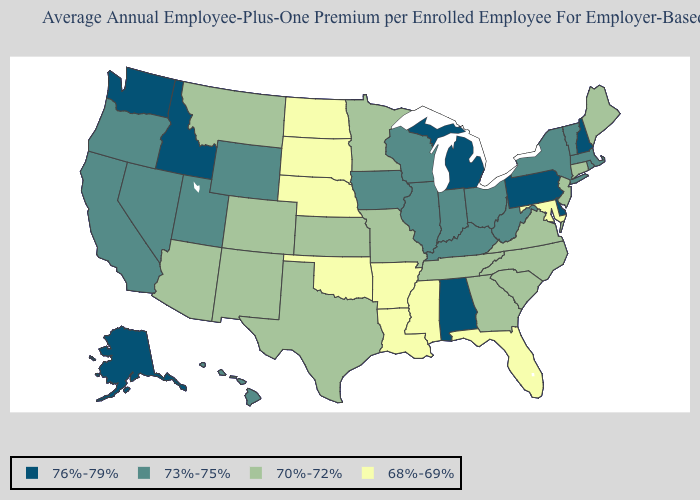What is the value of New Mexico?
Give a very brief answer. 70%-72%. Name the states that have a value in the range 70%-72%?
Be succinct. Arizona, Colorado, Connecticut, Georgia, Kansas, Maine, Minnesota, Missouri, Montana, New Jersey, New Mexico, North Carolina, South Carolina, Tennessee, Texas, Virginia. Which states have the lowest value in the West?
Concise answer only. Arizona, Colorado, Montana, New Mexico. Name the states that have a value in the range 70%-72%?
Write a very short answer. Arizona, Colorado, Connecticut, Georgia, Kansas, Maine, Minnesota, Missouri, Montana, New Jersey, New Mexico, North Carolina, South Carolina, Tennessee, Texas, Virginia. What is the lowest value in the West?
Keep it brief. 70%-72%. Does Oklahoma have a lower value than Louisiana?
Keep it brief. No. What is the lowest value in the USA?
Answer briefly. 68%-69%. Does Alaska have the same value as Maryland?
Answer briefly. No. Which states have the lowest value in the MidWest?
Give a very brief answer. Nebraska, North Dakota, South Dakota. Name the states that have a value in the range 73%-75%?
Write a very short answer. California, Hawaii, Illinois, Indiana, Iowa, Kentucky, Massachusetts, Nevada, New York, Ohio, Oregon, Rhode Island, Utah, Vermont, West Virginia, Wisconsin, Wyoming. What is the value of Wyoming?
Write a very short answer. 73%-75%. Name the states that have a value in the range 70%-72%?
Write a very short answer. Arizona, Colorado, Connecticut, Georgia, Kansas, Maine, Minnesota, Missouri, Montana, New Jersey, New Mexico, North Carolina, South Carolina, Tennessee, Texas, Virginia. What is the highest value in the South ?
Be succinct. 76%-79%. What is the lowest value in states that border New Hampshire?
Concise answer only. 70%-72%. Does Mississippi have the highest value in the South?
Answer briefly. No. 